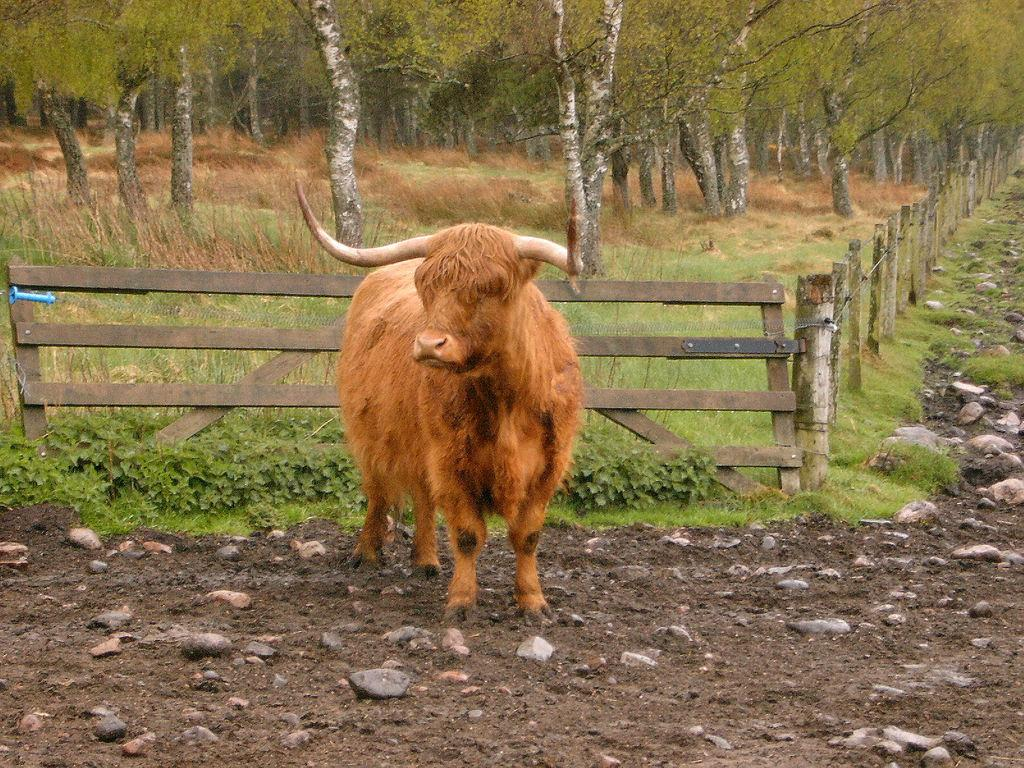What type of living creature is in the image? There is an animal in the image. What is the animal standing on? The animal is standing on land with rocks. What is located behind the animal? There is a fence behind the animal. What can be seen in the background of the image? There are plants and trees on the grassland in the background. What is the weight of the fireman in the image? There is no fireman present in the image. Can you tell me how many horses are visible in the image? There are no horses visible in the image; it features an animal standing on land with rocks. 